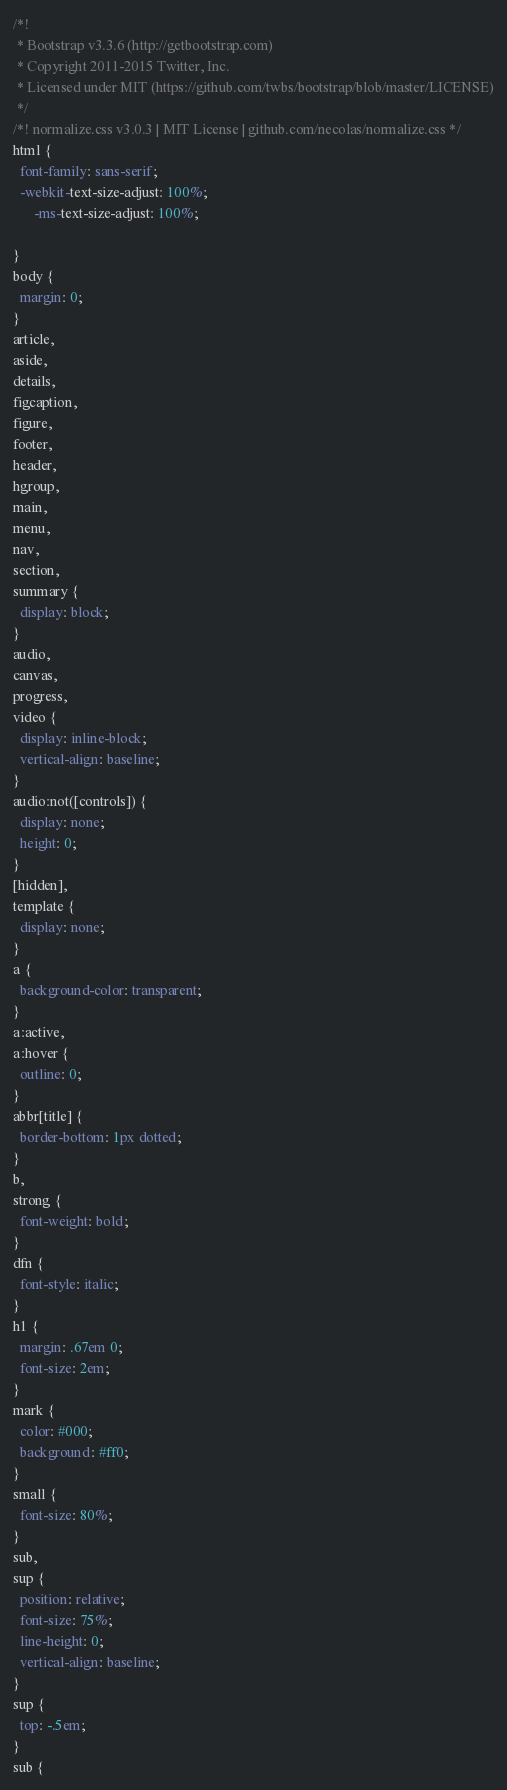Convert code to text. <code><loc_0><loc_0><loc_500><loc_500><_CSS_>/*!
 * Bootstrap v3.3.6 (http://getbootstrap.com)
 * Copyright 2011-2015 Twitter, Inc.
 * Licensed under MIT (https://github.com/twbs/bootstrap/blob/master/LICENSE)
 */
/*! normalize.css v3.0.3 | MIT License | github.com/necolas/normalize.css */
html {
  font-family: sans-serif;
  -webkit-text-size-adjust: 100%;
      -ms-text-size-adjust: 100%;
      
}
body {
  margin: 0;
}
article,
aside,
details,
figcaption,
figure,
footer,
header,
hgroup,
main,
menu,
nav,
section,
summary {
  display: block;
}
audio,
canvas,
progress,
video {
  display: inline-block;
  vertical-align: baseline;
}
audio:not([controls]) {
  display: none;
  height: 0;
}
[hidden],
template {
  display: none;
}
a {
  background-color: transparent;
}
a:active,
a:hover {
  outline: 0;
}
abbr[title] {
  border-bottom: 1px dotted;
}
b,
strong {
  font-weight: bold;
}
dfn {
  font-style: italic;
}
h1 {
  margin: .67em 0;
  font-size: 2em;
}
mark {
  color: #000;
  background: #ff0;
}
small {
  font-size: 80%;
}
sub,
sup {
  position: relative;
  font-size: 75%;
  line-height: 0;
  vertical-align: baseline;
}
sup {
  top: -.5em;
}
sub {</code> 